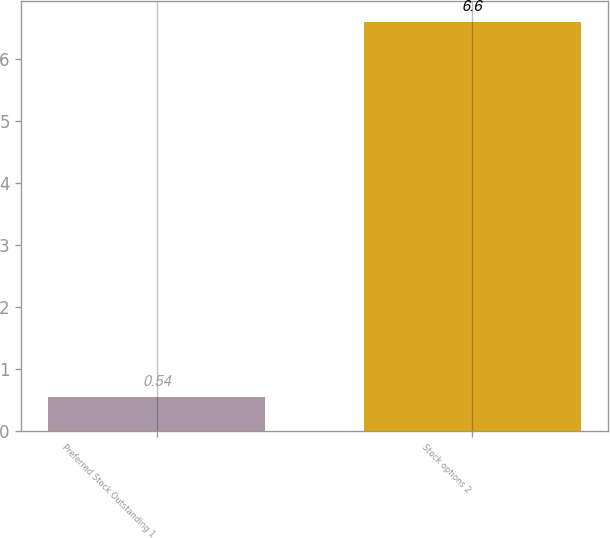Convert chart to OTSL. <chart><loc_0><loc_0><loc_500><loc_500><bar_chart><fcel>Preferred Stock Outstanding 1<fcel>Stock options 2<nl><fcel>0.54<fcel>6.6<nl></chart> 